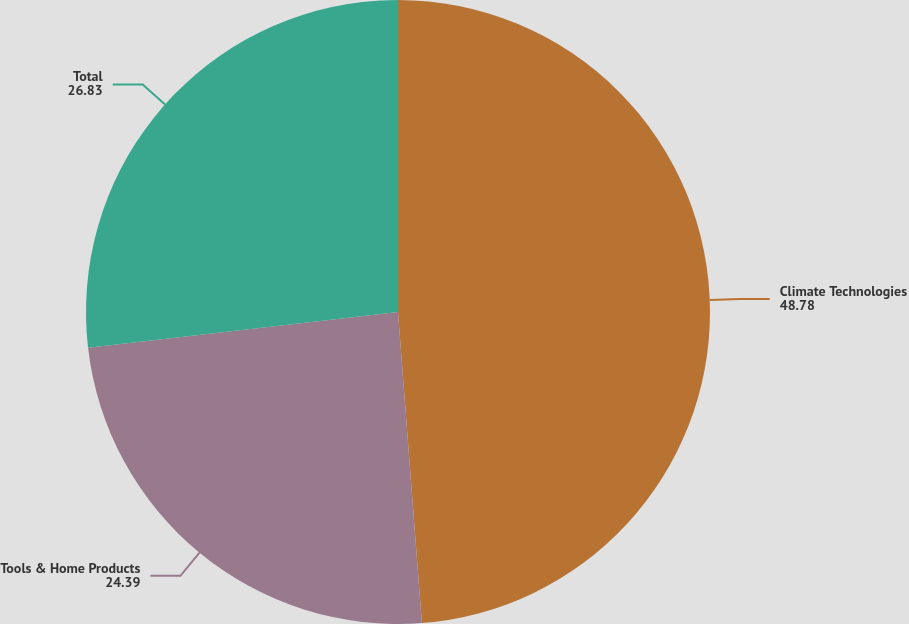Convert chart. <chart><loc_0><loc_0><loc_500><loc_500><pie_chart><fcel>Climate Technologies<fcel>Tools & Home Products<fcel>Total<nl><fcel>48.78%<fcel>24.39%<fcel>26.83%<nl></chart> 